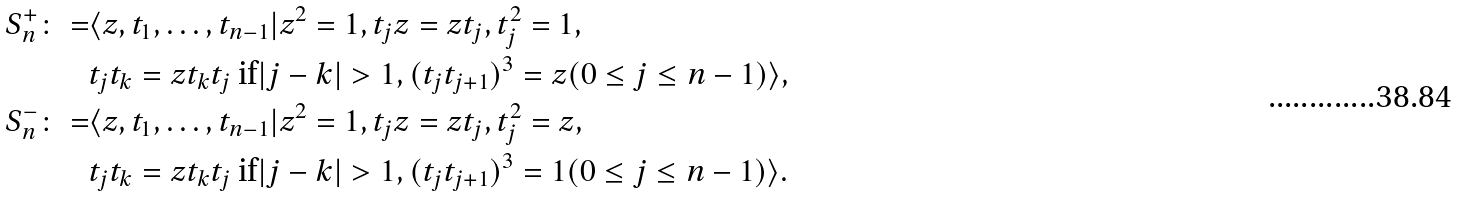<formula> <loc_0><loc_0><loc_500><loc_500>S ^ { + } _ { n } \colon = & \langle z , t _ { 1 } , \dots , t _ { n - 1 } | z ^ { 2 } = 1 , t _ { j } z = z t _ { j } , t _ { j } ^ { 2 } = 1 , \\ & t _ { j } t _ { k } = z t _ { k } t _ { j } \text { if} | j - k | > 1 , ( t _ { j } t _ { j + 1 } ) ^ { 3 } = z ( 0 \leq j \leq n - 1 ) \rangle , \\ S ^ { - } _ { n } \colon = & \langle z , t _ { 1 } , \dots , t _ { n - 1 } | z ^ { 2 } = 1 , t _ { j } z = z t _ { j } , t _ { j } ^ { 2 } = z , \\ & t _ { j } t _ { k } = z t _ { k } t _ { j } \text { if} | j - k | > 1 , ( t _ { j } t _ { j + 1 } ) ^ { 3 } = 1 ( 0 \leq j \leq n - 1 ) \rangle .</formula> 